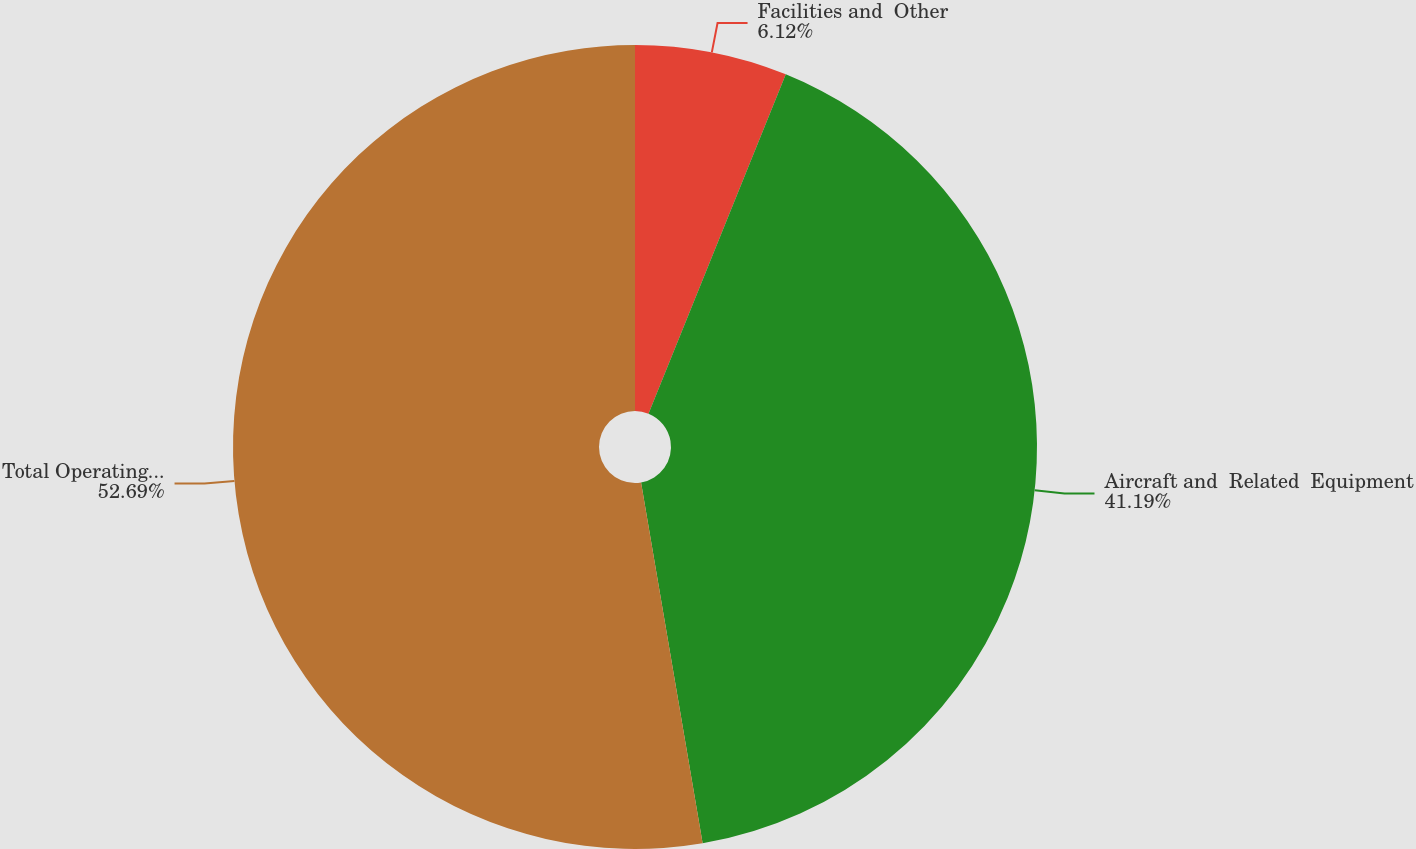Convert chart. <chart><loc_0><loc_0><loc_500><loc_500><pie_chart><fcel>Facilities and  Other<fcel>Aircraft and  Related  Equipment<fcel>Total Operating  Leases<nl><fcel>6.12%<fcel>41.19%<fcel>52.69%<nl></chart> 